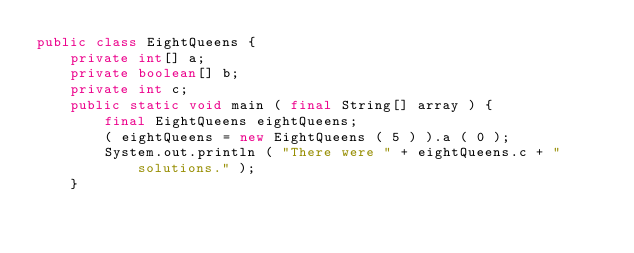Convert code to text. <code><loc_0><loc_0><loc_500><loc_500><_Java_>public class EightQueens {
    private int[] a;
    private boolean[] b;
    private int c;
    public static void main ( final String[] array ) {
        final EightQueens eightQueens;
        ( eightQueens = new EightQueens ( 5 ) ).a ( 0 );
        System.out.println ( "There were " + eightQueens.c + " solutions." );
    }</code> 